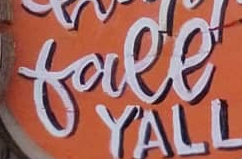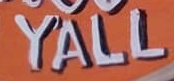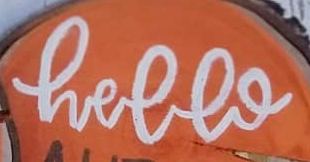Transcribe the words shown in these images in order, separated by a semicolon. free; YALL; hello 